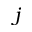<formula> <loc_0><loc_0><loc_500><loc_500>j</formula> 